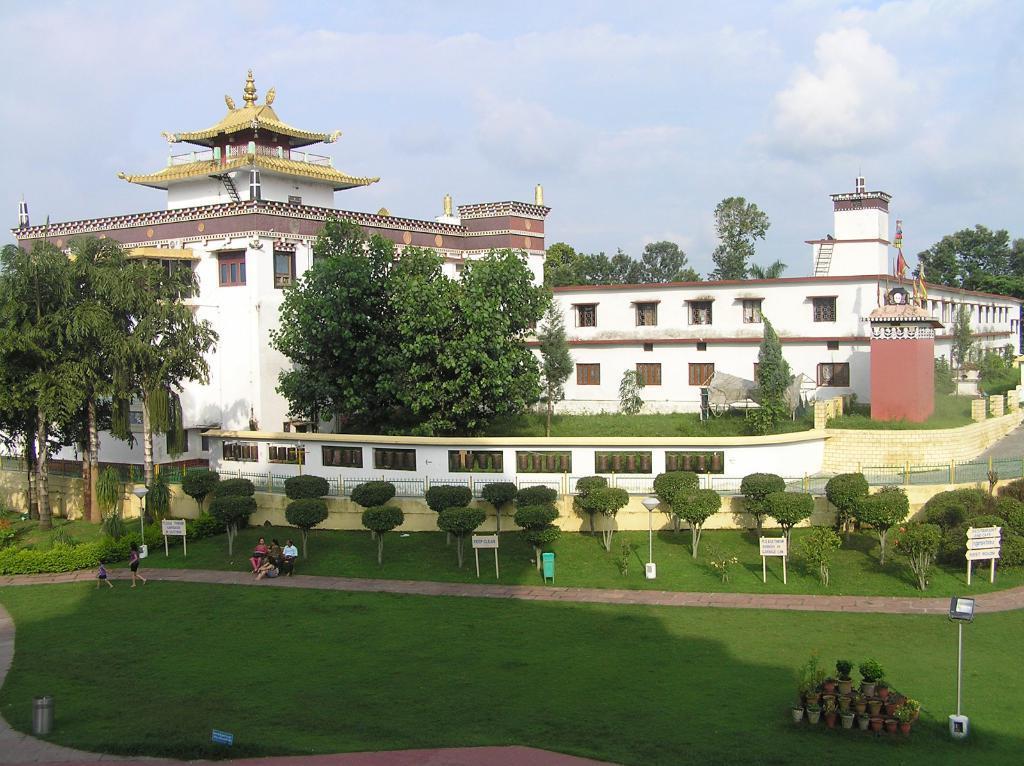Please provide a concise description of this image. In this image in the center there is a building, and there are some trees, tower, flags, poles, plants, trees and some objects and there is a railing and wall and some trees. And at the bottom of the image there is grass and some people are walking, and also there are some boards, flower pots, poles and some objects. At the top there is sky. 